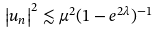Convert formula to latex. <formula><loc_0><loc_0><loc_500><loc_500>\left | u _ { n } \right | ^ { 2 } \lesssim \mu ^ { 2 } ( 1 - e ^ { 2 \lambda } ) ^ { - 1 }</formula> 